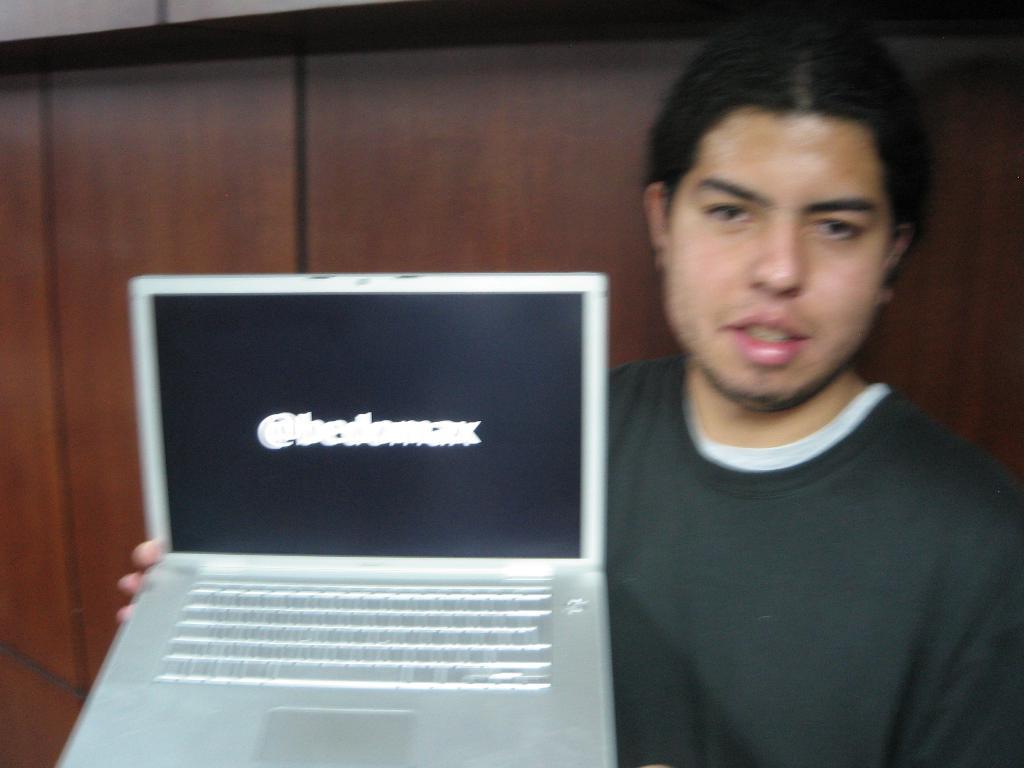Describe this image in one or two sentences. In this image, I can see a person holding a laptop. In the background there is a wooden wall. 